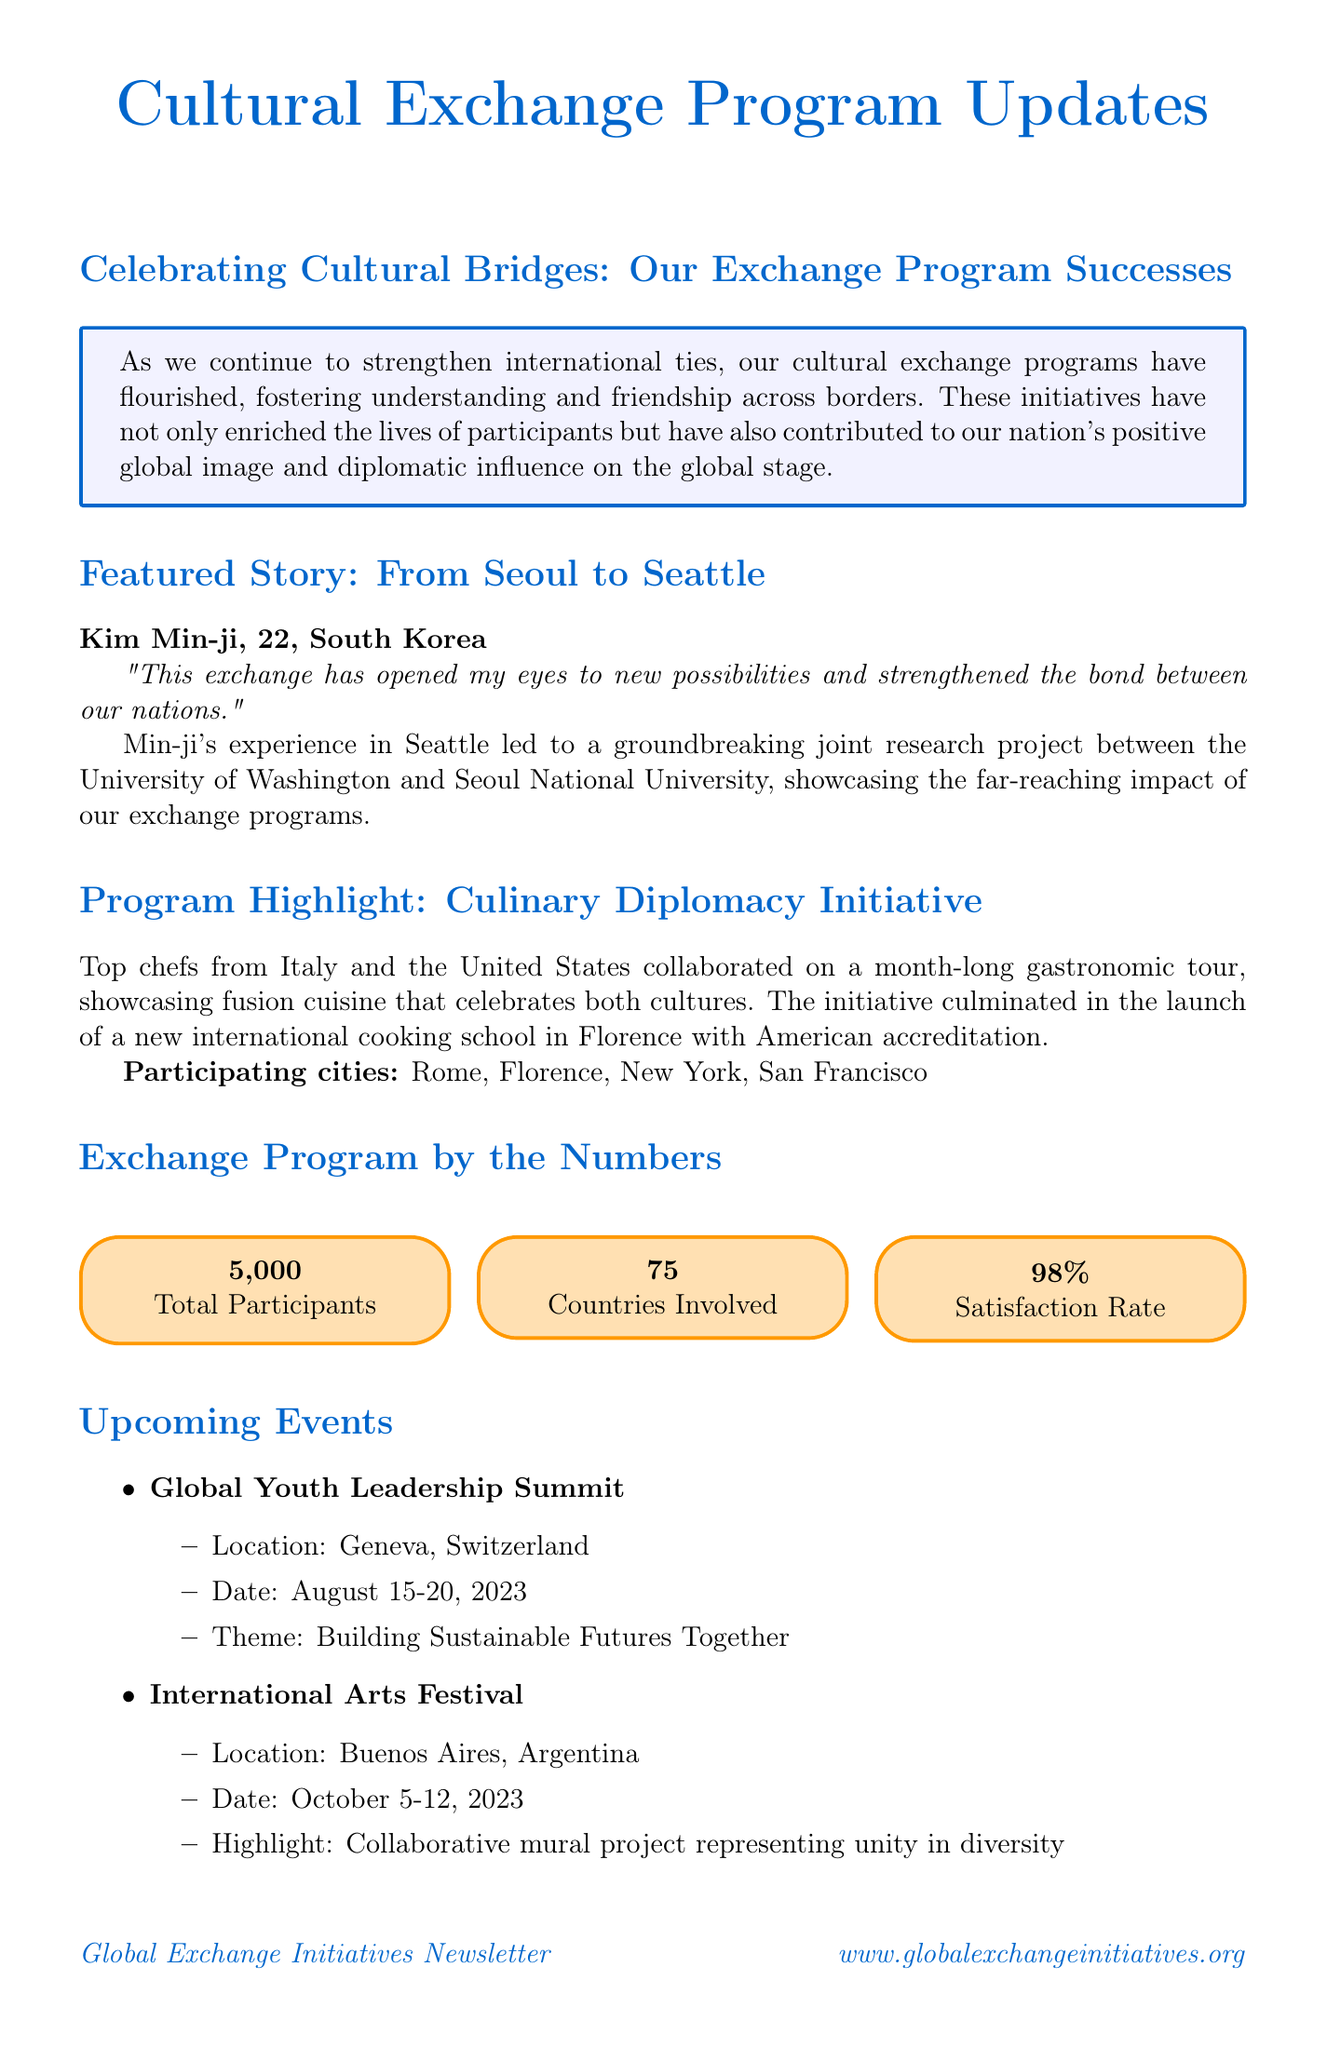What is the title of the featured story? The title of the featured story highlights the cultural exchange experience between two cities.
Answer: From Seoul to Seattle How many total participants are reported in the exchange program? The document states a specific number indicating the scale of participant involvement in the exchange programs.
Answer: 5000 What is the satisfaction rate for the exchange programs? The satisfaction rate reflects the participants' approval of the exchange programs.
Answer: 98% What is the location of the upcoming Global Youth Leadership Summit? This question seeks to identify the city where a significant upcoming event related to the exchange program is taking place.
Answer: Geneva, Switzerland Which organization sponsored the Culinary Diplomacy Initiative? This initiative involves notable chefs and aims to highlight culinary collaboration, reflecting an aspect of cultural exchange.
Answer: Not specified What is the theme of the Global Youth Leadership Summit? The theme indicates the focus of the summit, emphasizing the goals of the event.
Answer: Building Sustainable Futures Together What kind of project is highlighted at the International Arts Festival? This project represents a form of collaboration and creativity among participating countries.
Answer: Collaborative mural project representing unity in diversity Who is the director of international education at Stanford University? This inquiry seeks to identify an expert who endorses the value of cultural exchange programs in the document.
Answer: Dr. Sarah Johnson 